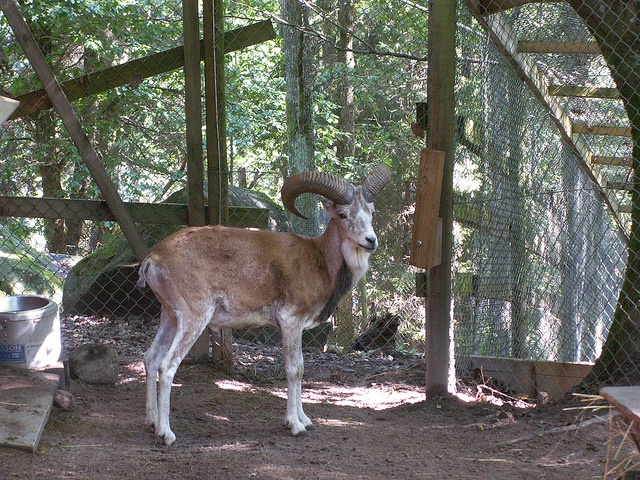Describe the objects in this image and their specific colors. I can see a sheep in gray, darkgray, and maroon tones in this image. 